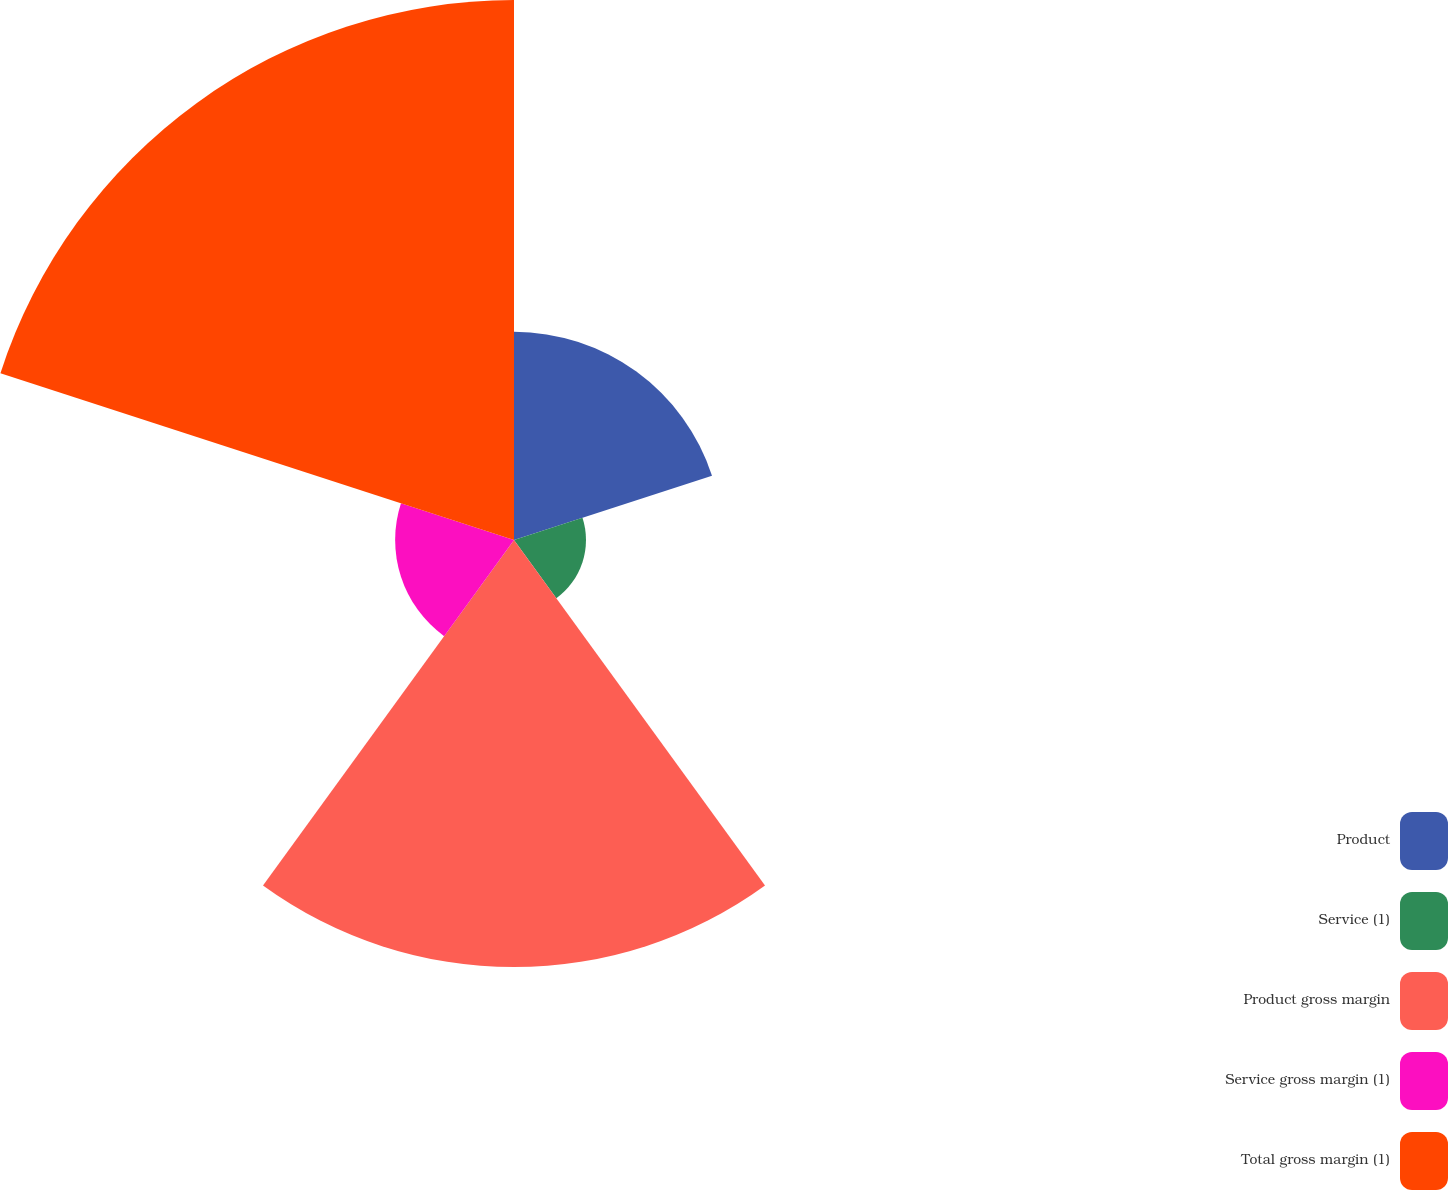<chart> <loc_0><loc_0><loc_500><loc_500><pie_chart><fcel>Product<fcel>Service (1)<fcel>Product gross margin<fcel>Service gross margin (1)<fcel>Total gross margin (1)<nl><fcel>15.24%<fcel>5.27%<fcel>31.26%<fcel>8.7%<fcel>39.53%<nl></chart> 